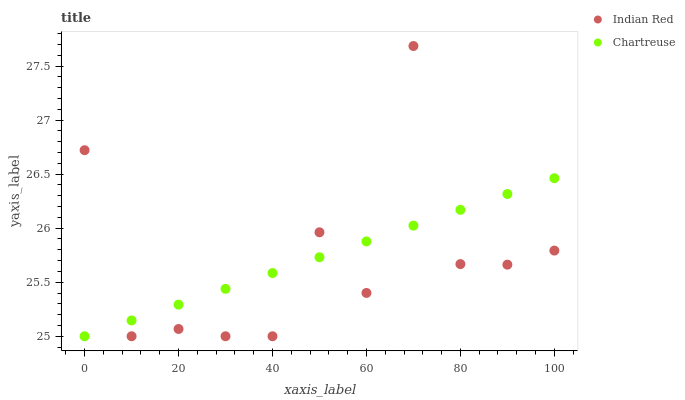Does Indian Red have the minimum area under the curve?
Answer yes or no. Yes. Does Chartreuse have the maximum area under the curve?
Answer yes or no. Yes. Does Indian Red have the maximum area under the curve?
Answer yes or no. No. Is Chartreuse the smoothest?
Answer yes or no. Yes. Is Indian Red the roughest?
Answer yes or no. Yes. Is Indian Red the smoothest?
Answer yes or no. No. Does Chartreuse have the lowest value?
Answer yes or no. Yes. Does Indian Red have the highest value?
Answer yes or no. Yes. Does Indian Red intersect Chartreuse?
Answer yes or no. Yes. Is Indian Red less than Chartreuse?
Answer yes or no. No. Is Indian Red greater than Chartreuse?
Answer yes or no. No. 